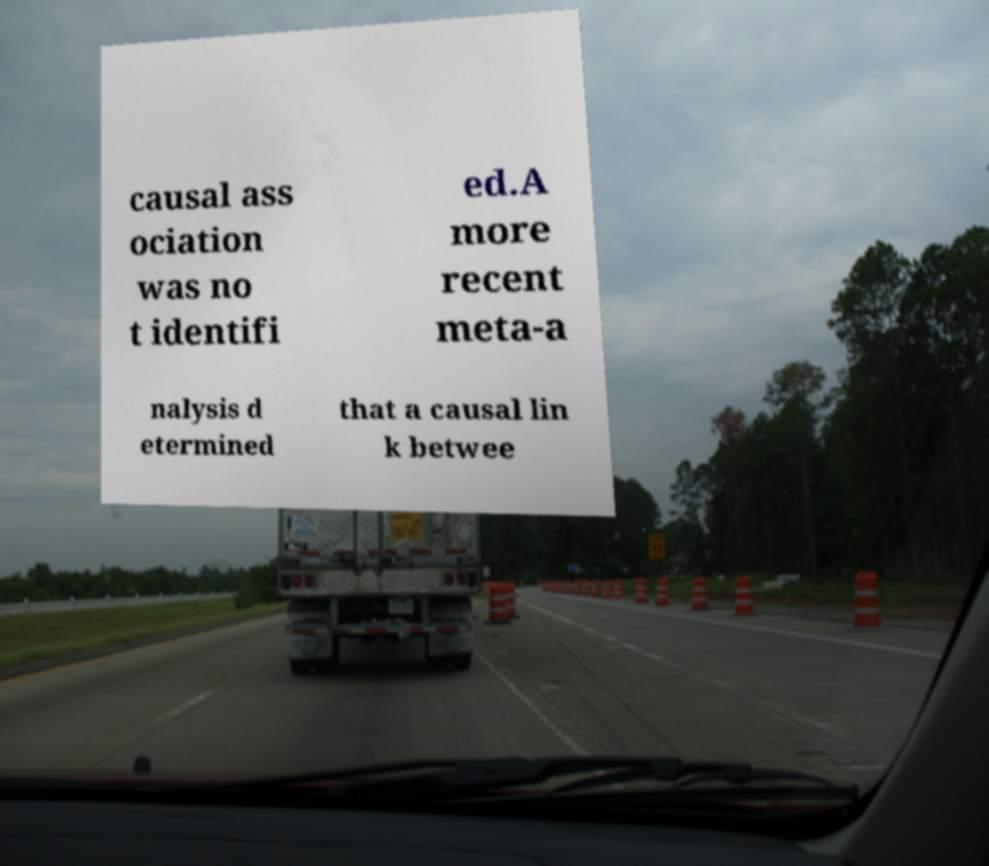There's text embedded in this image that I need extracted. Can you transcribe it verbatim? causal ass ociation was no t identifi ed.A more recent meta-a nalysis d etermined that a causal lin k betwee 